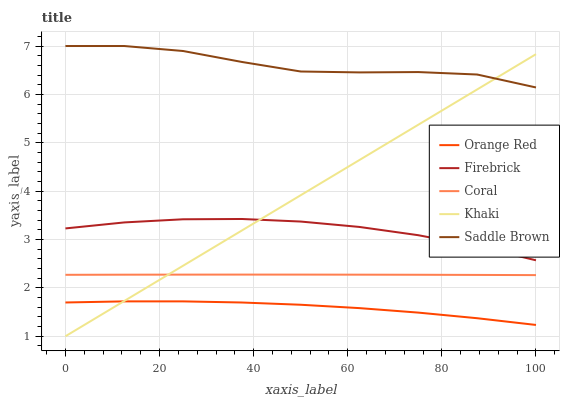Does Orange Red have the minimum area under the curve?
Answer yes or no. Yes. Does Saddle Brown have the maximum area under the curve?
Answer yes or no. Yes. Does Firebrick have the minimum area under the curve?
Answer yes or no. No. Does Firebrick have the maximum area under the curve?
Answer yes or no. No. Is Khaki the smoothest?
Answer yes or no. Yes. Is Saddle Brown the roughest?
Answer yes or no. Yes. Is Firebrick the smoothest?
Answer yes or no. No. Is Firebrick the roughest?
Answer yes or no. No. Does Firebrick have the lowest value?
Answer yes or no. No. Does Saddle Brown have the highest value?
Answer yes or no. Yes. Does Firebrick have the highest value?
Answer yes or no. No. Is Orange Red less than Saddle Brown?
Answer yes or no. Yes. Is Firebrick greater than Orange Red?
Answer yes or no. Yes. Does Khaki intersect Coral?
Answer yes or no. Yes. Is Khaki less than Coral?
Answer yes or no. No. Is Khaki greater than Coral?
Answer yes or no. No. Does Orange Red intersect Saddle Brown?
Answer yes or no. No. 